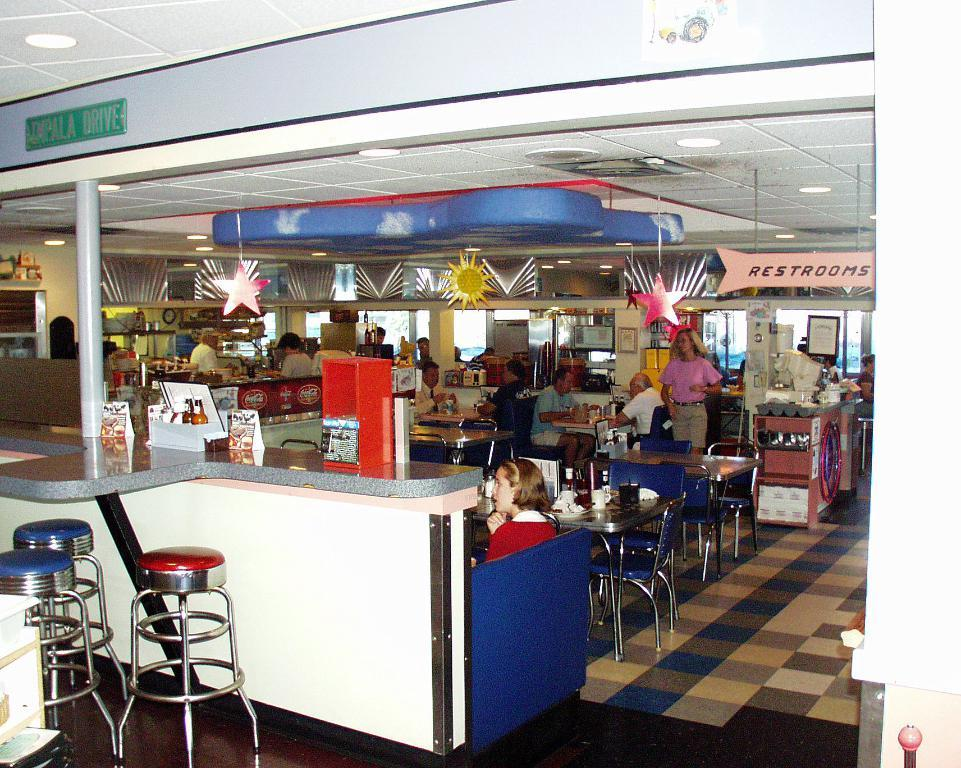How many people are in the image? There are people in the image, but the exact number is not specified. What are some of the people doing in the image? Some people are standing, and some are sitting on chairs. What type of furniture is present in the image? There are chairs and stools in the image. What can be seen in the image that adds to the visual appeal? There are decorations in the image. What language are the fairies speaking in the image? There are no fairies present in the image, so it is not possible to determine the language they might be speaking. 